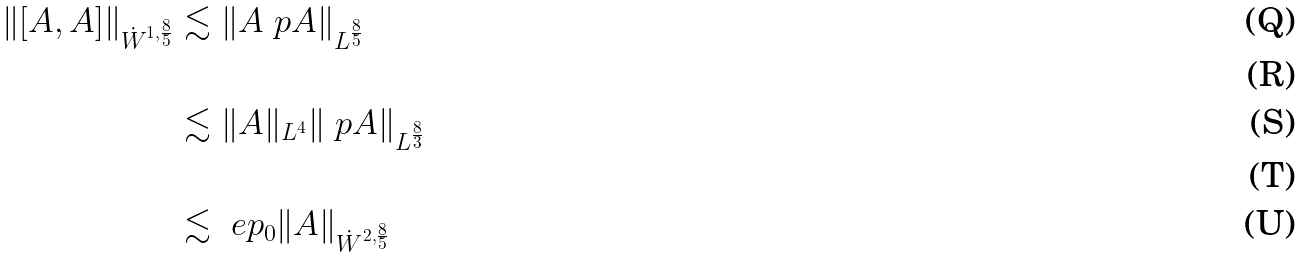<formula> <loc_0><loc_0><loc_500><loc_500>\| [ A , A ] \| _ { \dot { W } ^ { 1 , \frac { 8 } { 5 } } } & \lesssim \| A \ p A \| _ { L ^ { \frac { 8 } { 5 } } } \\ \\ & \lesssim \| A \| _ { L ^ { 4 } } \| \ p A \| _ { L ^ { \frac { 8 } { 3 } } } \\ \\ & \lesssim \ e p _ { 0 } \| A \| _ { \dot { W } ^ { 2 , \frac { 8 } { 5 } } }</formula> 